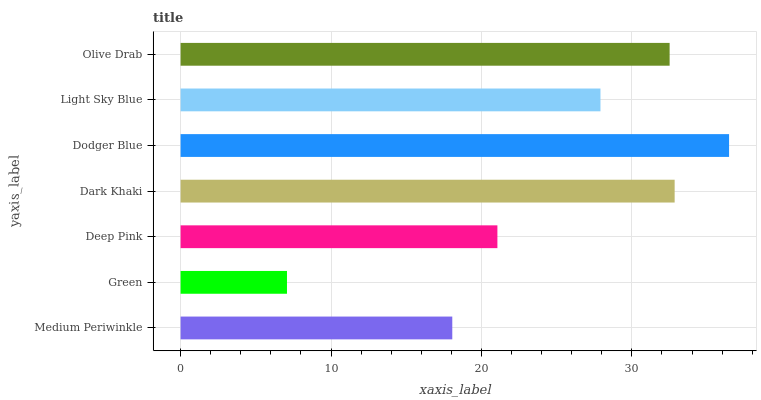Is Green the minimum?
Answer yes or no. Yes. Is Dodger Blue the maximum?
Answer yes or no. Yes. Is Deep Pink the minimum?
Answer yes or no. No. Is Deep Pink the maximum?
Answer yes or no. No. Is Deep Pink greater than Green?
Answer yes or no. Yes. Is Green less than Deep Pink?
Answer yes or no. Yes. Is Green greater than Deep Pink?
Answer yes or no. No. Is Deep Pink less than Green?
Answer yes or no. No. Is Light Sky Blue the high median?
Answer yes or no. Yes. Is Light Sky Blue the low median?
Answer yes or no. Yes. Is Olive Drab the high median?
Answer yes or no. No. Is Deep Pink the low median?
Answer yes or no. No. 